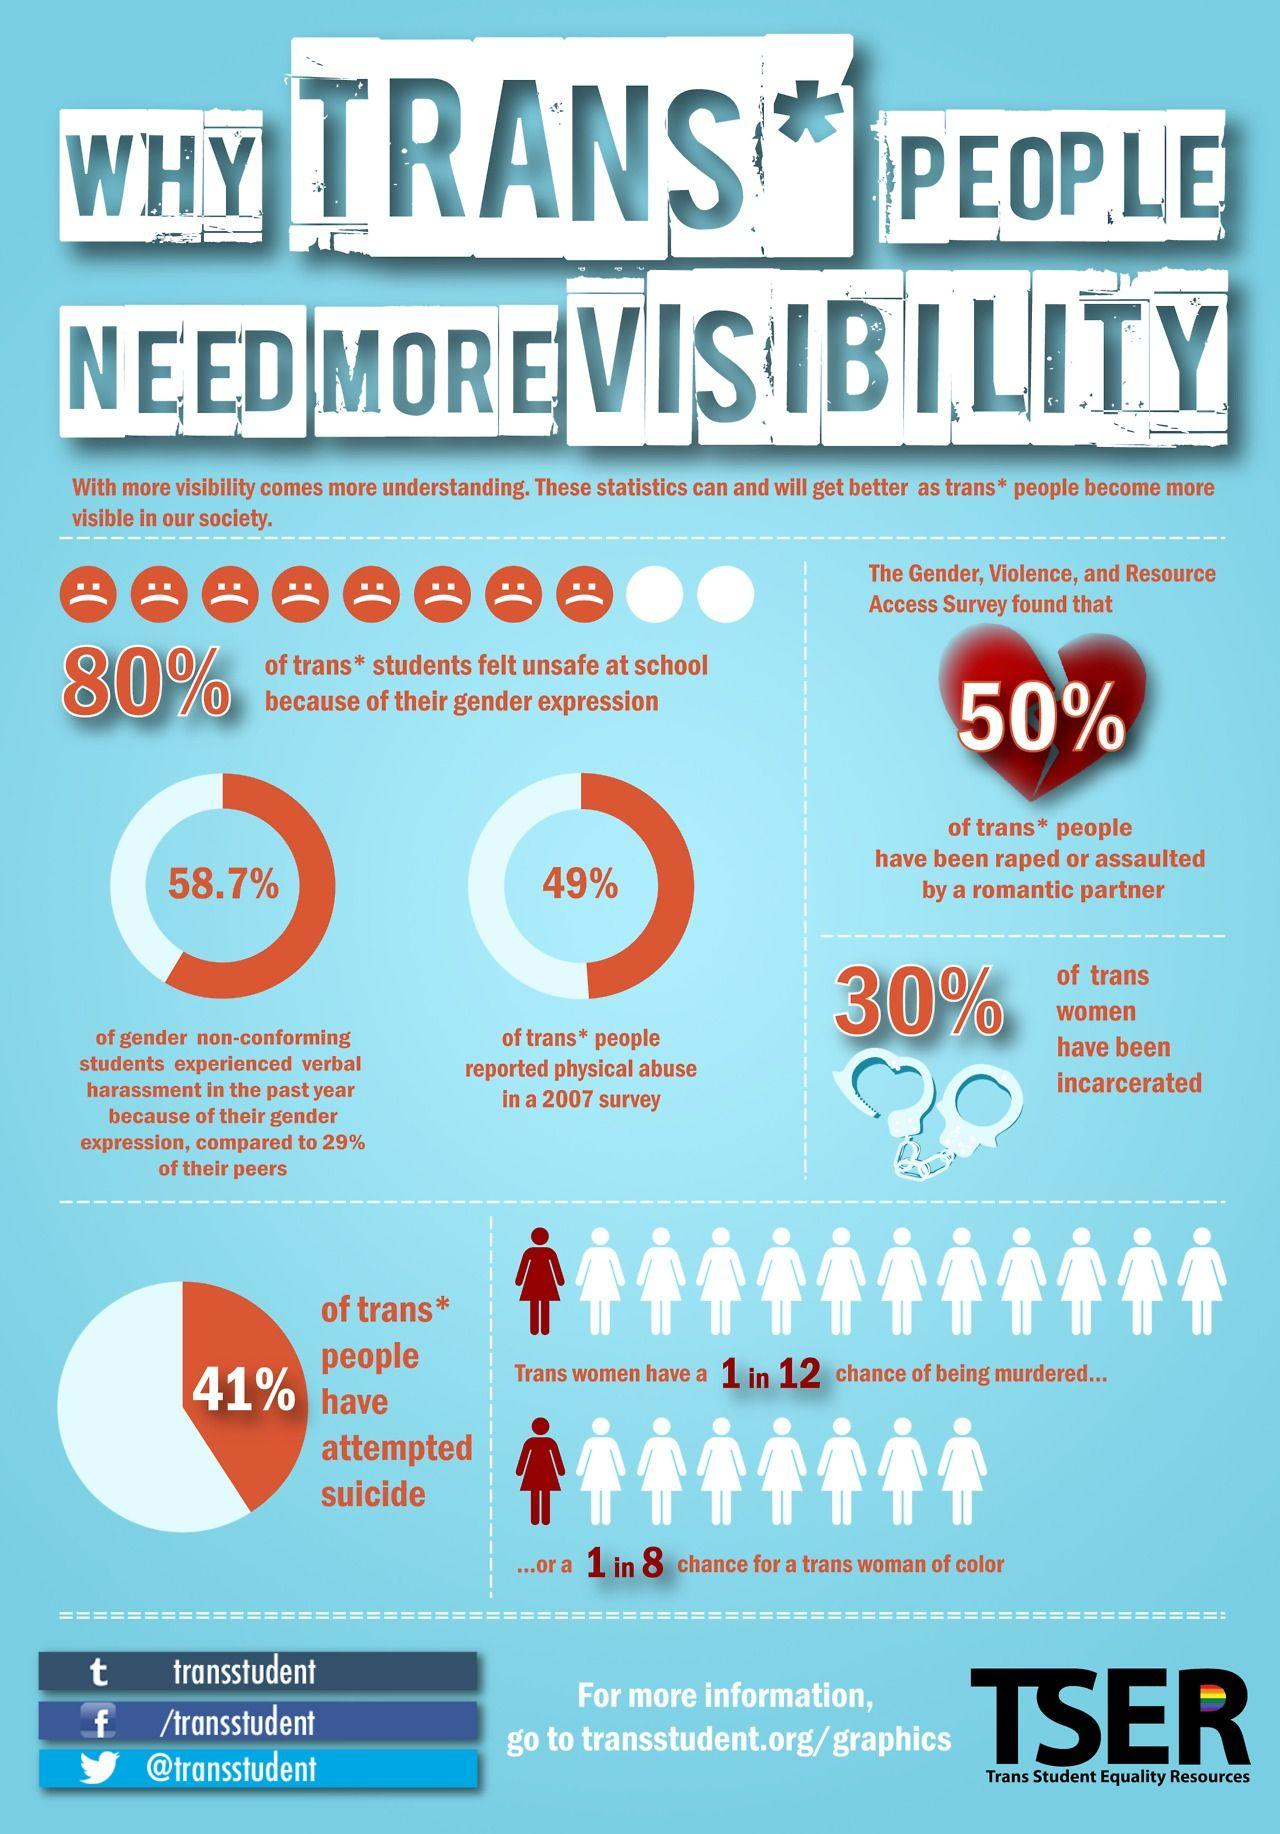Indicate a few pertinent items in this graphic. The Twitter handle given is "@transstudent." The use of Twitter handle gives the information that the account belongs to a person or organization with the name "transstudent. The Facebook profile in question is that of a transgender student. 